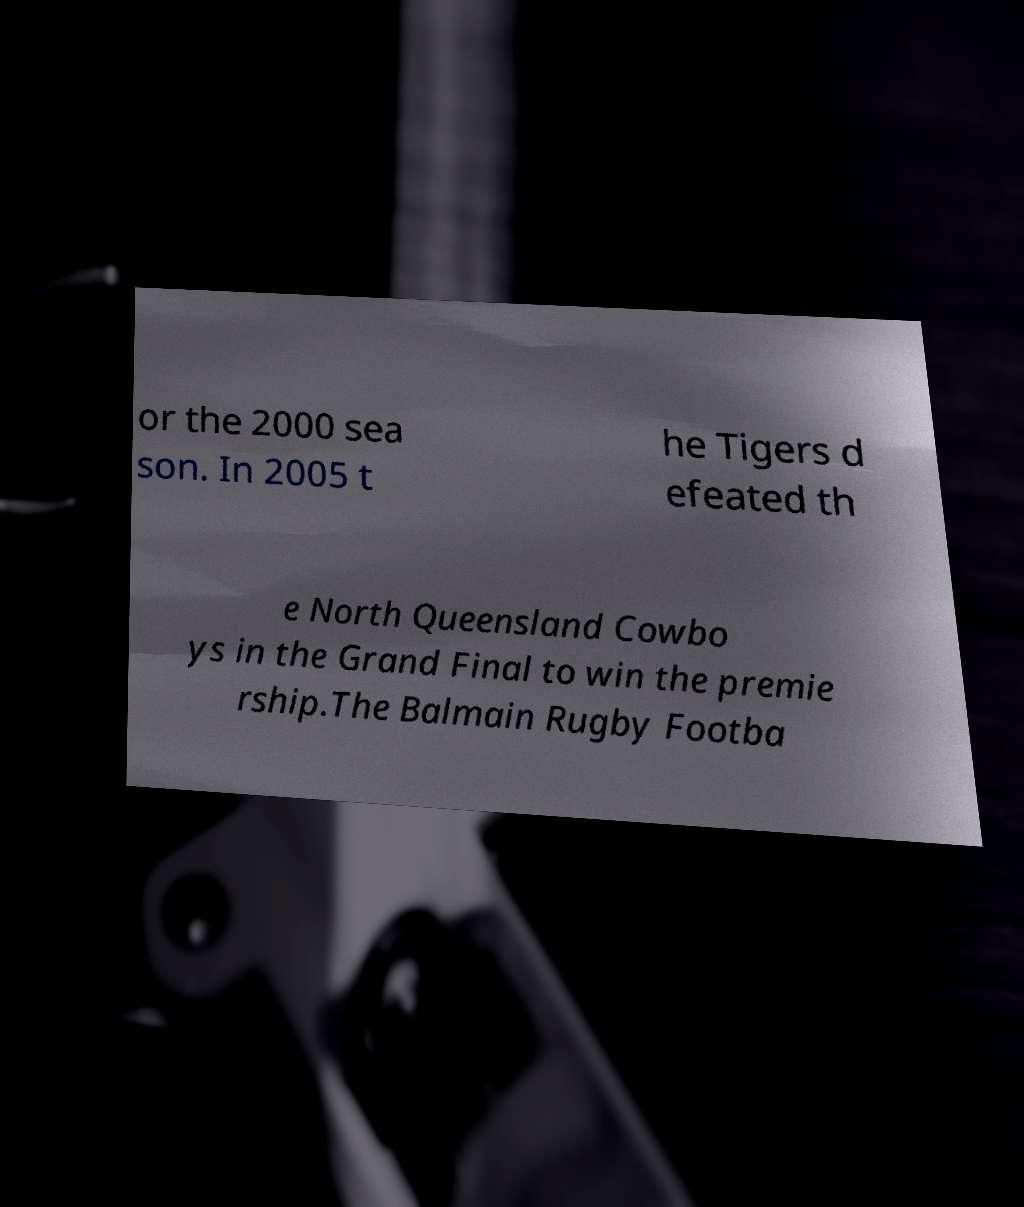Could you assist in decoding the text presented in this image and type it out clearly? or the 2000 sea son. In 2005 t he Tigers d efeated th e North Queensland Cowbo ys in the Grand Final to win the premie rship.The Balmain Rugby Footba 